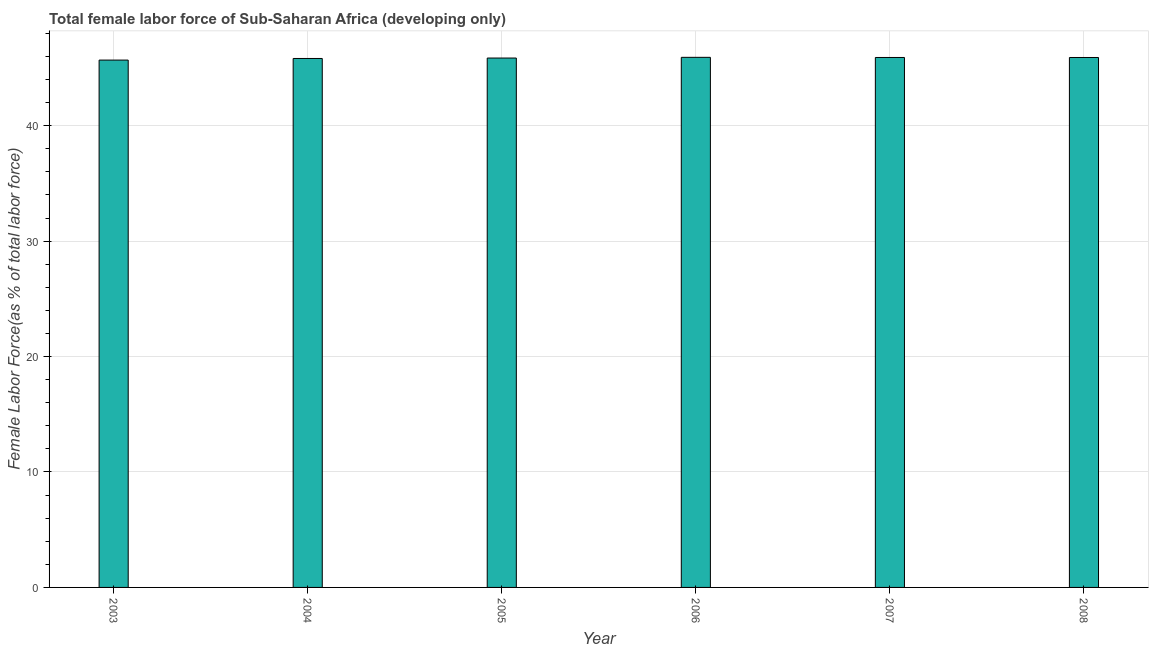What is the title of the graph?
Make the answer very short. Total female labor force of Sub-Saharan Africa (developing only). What is the label or title of the Y-axis?
Give a very brief answer. Female Labor Force(as % of total labor force). What is the total female labor force in 2006?
Offer a terse response. 45.92. Across all years, what is the maximum total female labor force?
Make the answer very short. 45.92. Across all years, what is the minimum total female labor force?
Your answer should be compact. 45.68. What is the sum of the total female labor force?
Your response must be concise. 275.11. What is the difference between the total female labor force in 2004 and 2007?
Your response must be concise. -0.09. What is the average total female labor force per year?
Ensure brevity in your answer.  45.85. What is the median total female labor force?
Your response must be concise. 45.88. In how many years, is the total female labor force greater than 14 %?
Your answer should be very brief. 6. Do a majority of the years between 2003 and 2005 (inclusive) have total female labor force greater than 46 %?
Make the answer very short. No. Is the total female labor force in 2006 less than that in 2007?
Provide a short and direct response. No. What is the difference between the highest and the second highest total female labor force?
Offer a terse response. 0.01. What is the difference between the highest and the lowest total female labor force?
Provide a short and direct response. 0.24. How many bars are there?
Your answer should be very brief. 6. Are all the bars in the graph horizontal?
Provide a succinct answer. No. What is the difference between two consecutive major ticks on the Y-axis?
Provide a short and direct response. 10. What is the Female Labor Force(as % of total labor force) in 2003?
Provide a succinct answer. 45.68. What is the Female Labor Force(as % of total labor force) of 2004?
Your answer should be compact. 45.82. What is the Female Labor Force(as % of total labor force) of 2005?
Offer a terse response. 45.86. What is the Female Labor Force(as % of total labor force) of 2006?
Your answer should be very brief. 45.92. What is the Female Labor Force(as % of total labor force) in 2007?
Ensure brevity in your answer.  45.91. What is the Female Labor Force(as % of total labor force) of 2008?
Your answer should be compact. 45.91. What is the difference between the Female Labor Force(as % of total labor force) in 2003 and 2004?
Offer a terse response. -0.14. What is the difference between the Female Labor Force(as % of total labor force) in 2003 and 2005?
Keep it short and to the point. -0.18. What is the difference between the Female Labor Force(as % of total labor force) in 2003 and 2006?
Your response must be concise. -0.24. What is the difference between the Female Labor Force(as % of total labor force) in 2003 and 2007?
Ensure brevity in your answer.  -0.23. What is the difference between the Female Labor Force(as % of total labor force) in 2003 and 2008?
Keep it short and to the point. -0.22. What is the difference between the Female Labor Force(as % of total labor force) in 2004 and 2005?
Make the answer very short. -0.04. What is the difference between the Female Labor Force(as % of total labor force) in 2004 and 2006?
Provide a succinct answer. -0.1. What is the difference between the Female Labor Force(as % of total labor force) in 2004 and 2007?
Make the answer very short. -0.09. What is the difference between the Female Labor Force(as % of total labor force) in 2004 and 2008?
Give a very brief answer. -0.08. What is the difference between the Female Labor Force(as % of total labor force) in 2005 and 2006?
Offer a terse response. -0.06. What is the difference between the Female Labor Force(as % of total labor force) in 2005 and 2007?
Give a very brief answer. -0.05. What is the difference between the Female Labor Force(as % of total labor force) in 2005 and 2008?
Your answer should be compact. -0.05. What is the difference between the Female Labor Force(as % of total labor force) in 2006 and 2007?
Your answer should be compact. 0.01. What is the difference between the Female Labor Force(as % of total labor force) in 2006 and 2008?
Provide a succinct answer. 0.01. What is the difference between the Female Labor Force(as % of total labor force) in 2007 and 2008?
Your response must be concise. 0. What is the ratio of the Female Labor Force(as % of total labor force) in 2003 to that in 2005?
Keep it short and to the point. 1. What is the ratio of the Female Labor Force(as % of total labor force) in 2003 to that in 2006?
Ensure brevity in your answer.  0.99. What is the ratio of the Female Labor Force(as % of total labor force) in 2003 to that in 2007?
Your answer should be compact. 0.99. What is the ratio of the Female Labor Force(as % of total labor force) in 2003 to that in 2008?
Offer a terse response. 0.99. What is the ratio of the Female Labor Force(as % of total labor force) in 2004 to that in 2007?
Provide a short and direct response. 1. What is the ratio of the Female Labor Force(as % of total labor force) in 2005 to that in 2007?
Make the answer very short. 1. What is the ratio of the Female Labor Force(as % of total labor force) in 2007 to that in 2008?
Keep it short and to the point. 1. 